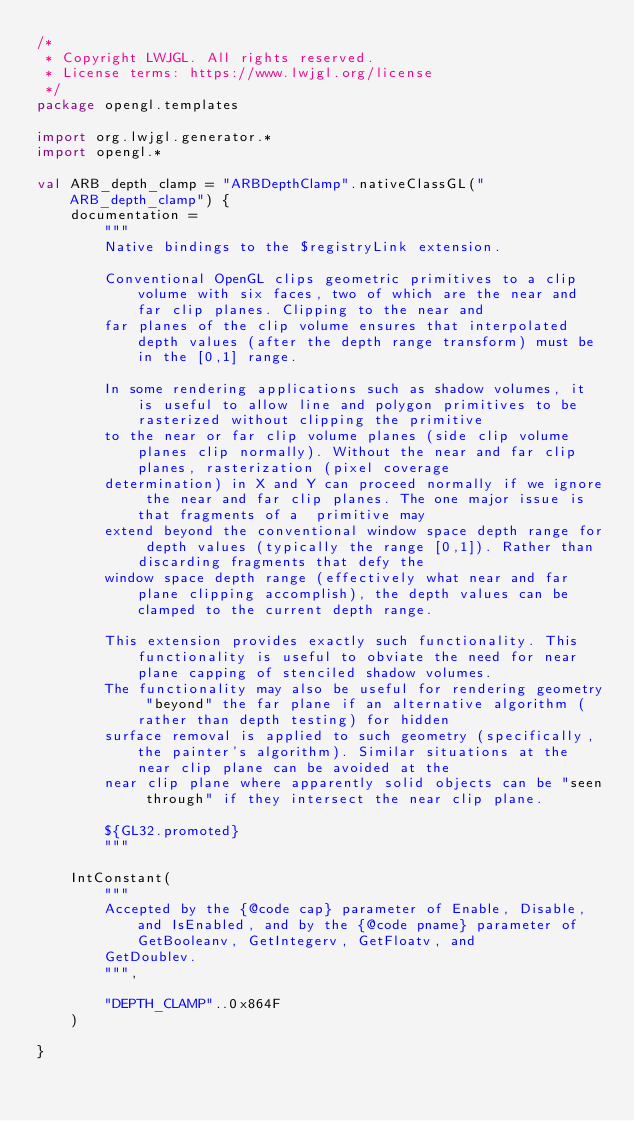Convert code to text. <code><loc_0><loc_0><loc_500><loc_500><_Kotlin_>/*
 * Copyright LWJGL. All rights reserved.
 * License terms: https://www.lwjgl.org/license
 */
package opengl.templates

import org.lwjgl.generator.*
import opengl.*

val ARB_depth_clamp = "ARBDepthClamp".nativeClassGL("ARB_depth_clamp") {
    documentation =
        """
        Native bindings to the $registryLink extension.

        Conventional OpenGL clips geometric primitives to a clip volume with six faces, two of which are the near and far clip planes. Clipping to the near and
        far planes of the clip volume ensures that interpolated depth values (after the depth range transform) must be in the [0,1] range.

        In some rendering applications such as shadow volumes, it is useful to allow line and polygon primitives to be rasterized without clipping the primitive
        to the near or far clip volume planes (side clip volume planes clip normally). Without the near and far clip planes, rasterization (pixel coverage
        determination) in X and Y can proceed normally if we ignore the near and far clip planes. The one major issue is that fragments of a  primitive may
        extend beyond the conventional window space depth range for depth values (typically the range [0,1]). Rather than discarding fragments that defy the
        window space depth range (effectively what near and far plane clipping accomplish), the depth values can be clamped to the current depth range.

        This extension provides exactly such functionality. This functionality is useful to obviate the need for near plane capping of stenciled shadow volumes.
        The functionality may also be useful for rendering geometry "beyond" the far plane if an alternative algorithm (rather than depth testing) for hidden
        surface removal is applied to such geometry (specifically, the painter's algorithm). Similar situations at the near clip plane can be avoided at the
        near clip plane where apparently solid objects can be "seen through" if they intersect the near clip plane.

        ${GL32.promoted}
        """

    IntConstant(
        """
        Accepted by the {@code cap} parameter of Enable, Disable, and IsEnabled, and by the {@code pname} parameter of GetBooleanv, GetIntegerv, GetFloatv, and
        GetDoublev.
        """,

        "DEPTH_CLAMP"..0x864F
    )

}</code> 